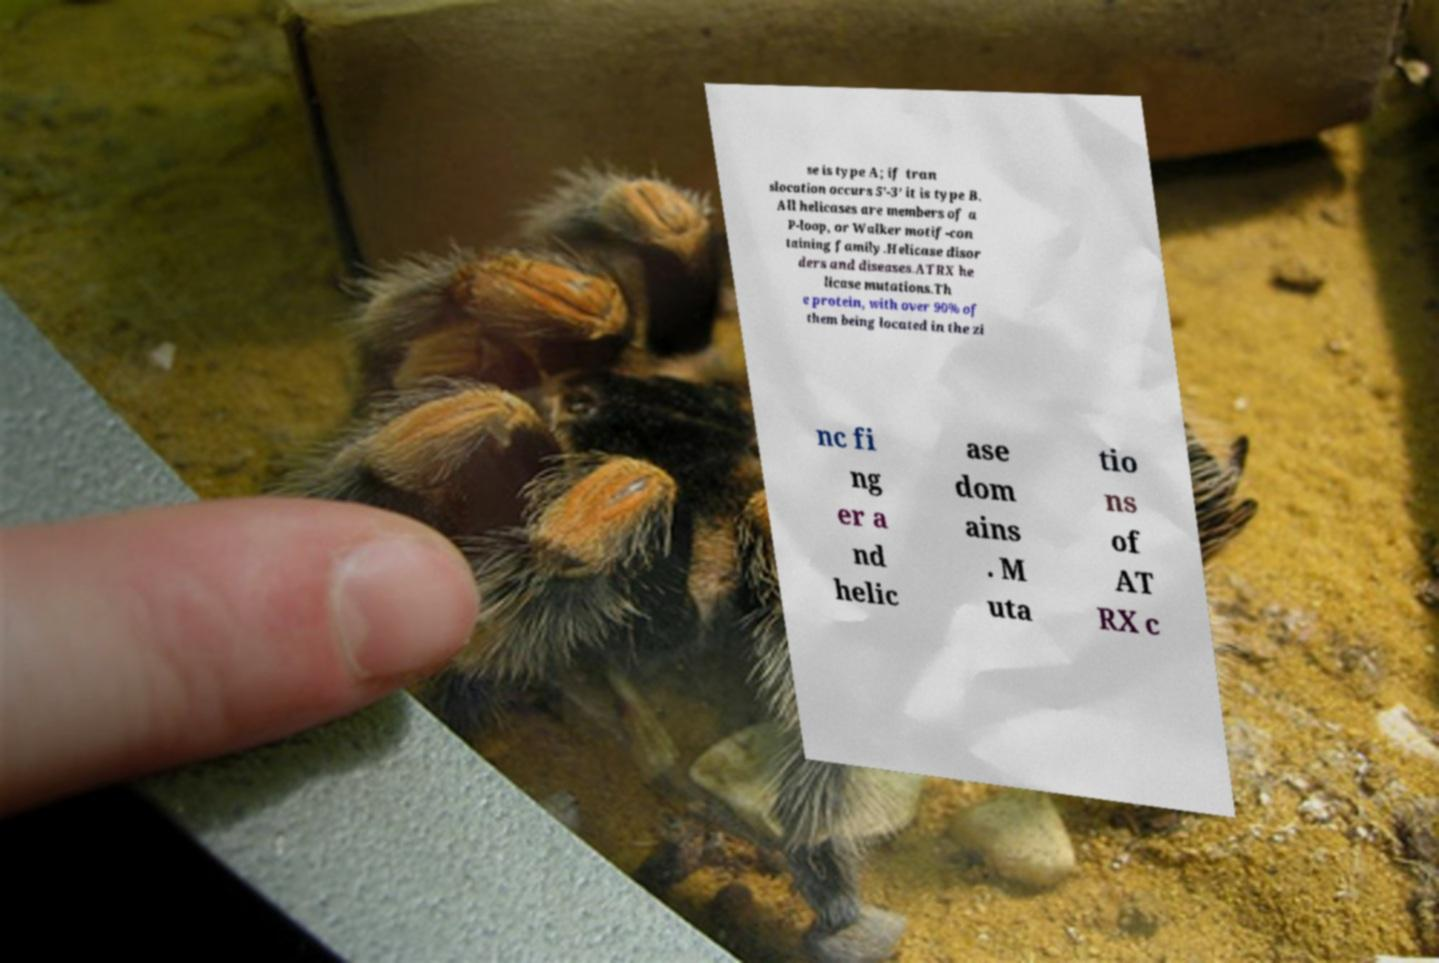I need the written content from this picture converted into text. Can you do that? se is type A; if tran slocation occurs 5’-3’ it is type B. All helicases are members of a P-loop, or Walker motif-con taining family.Helicase disor ders and diseases.ATRX he licase mutations.Th e protein, with over 90% of them being located in the zi nc fi ng er a nd helic ase dom ains . M uta tio ns of AT RX c 